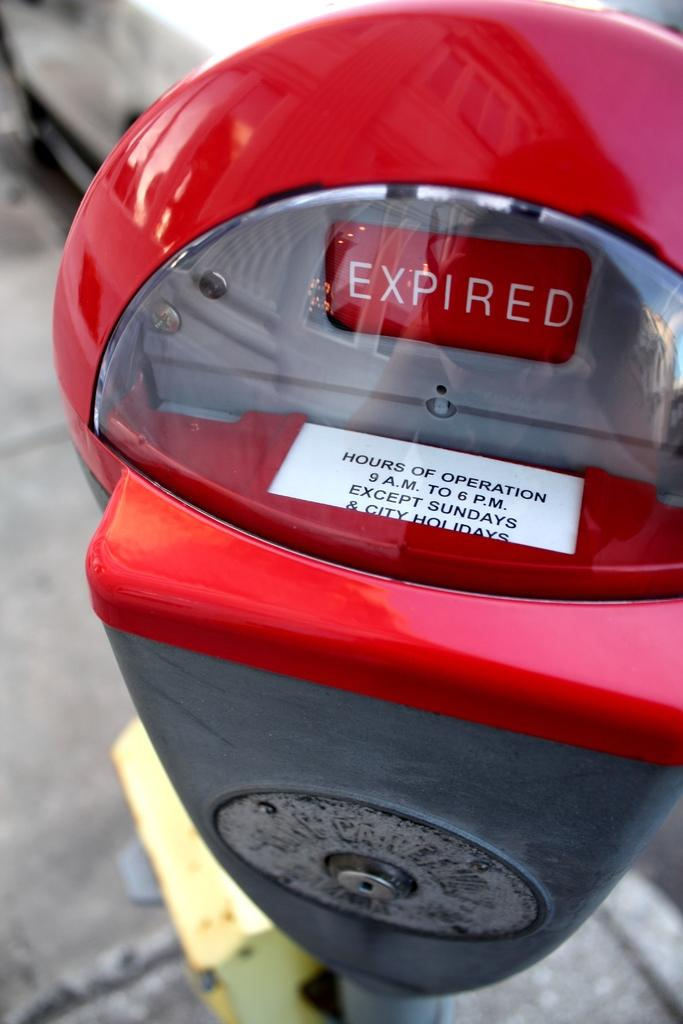<image>
Provide a brief description of the given image. a parking meter that has an expired tag on it and hours of operation 